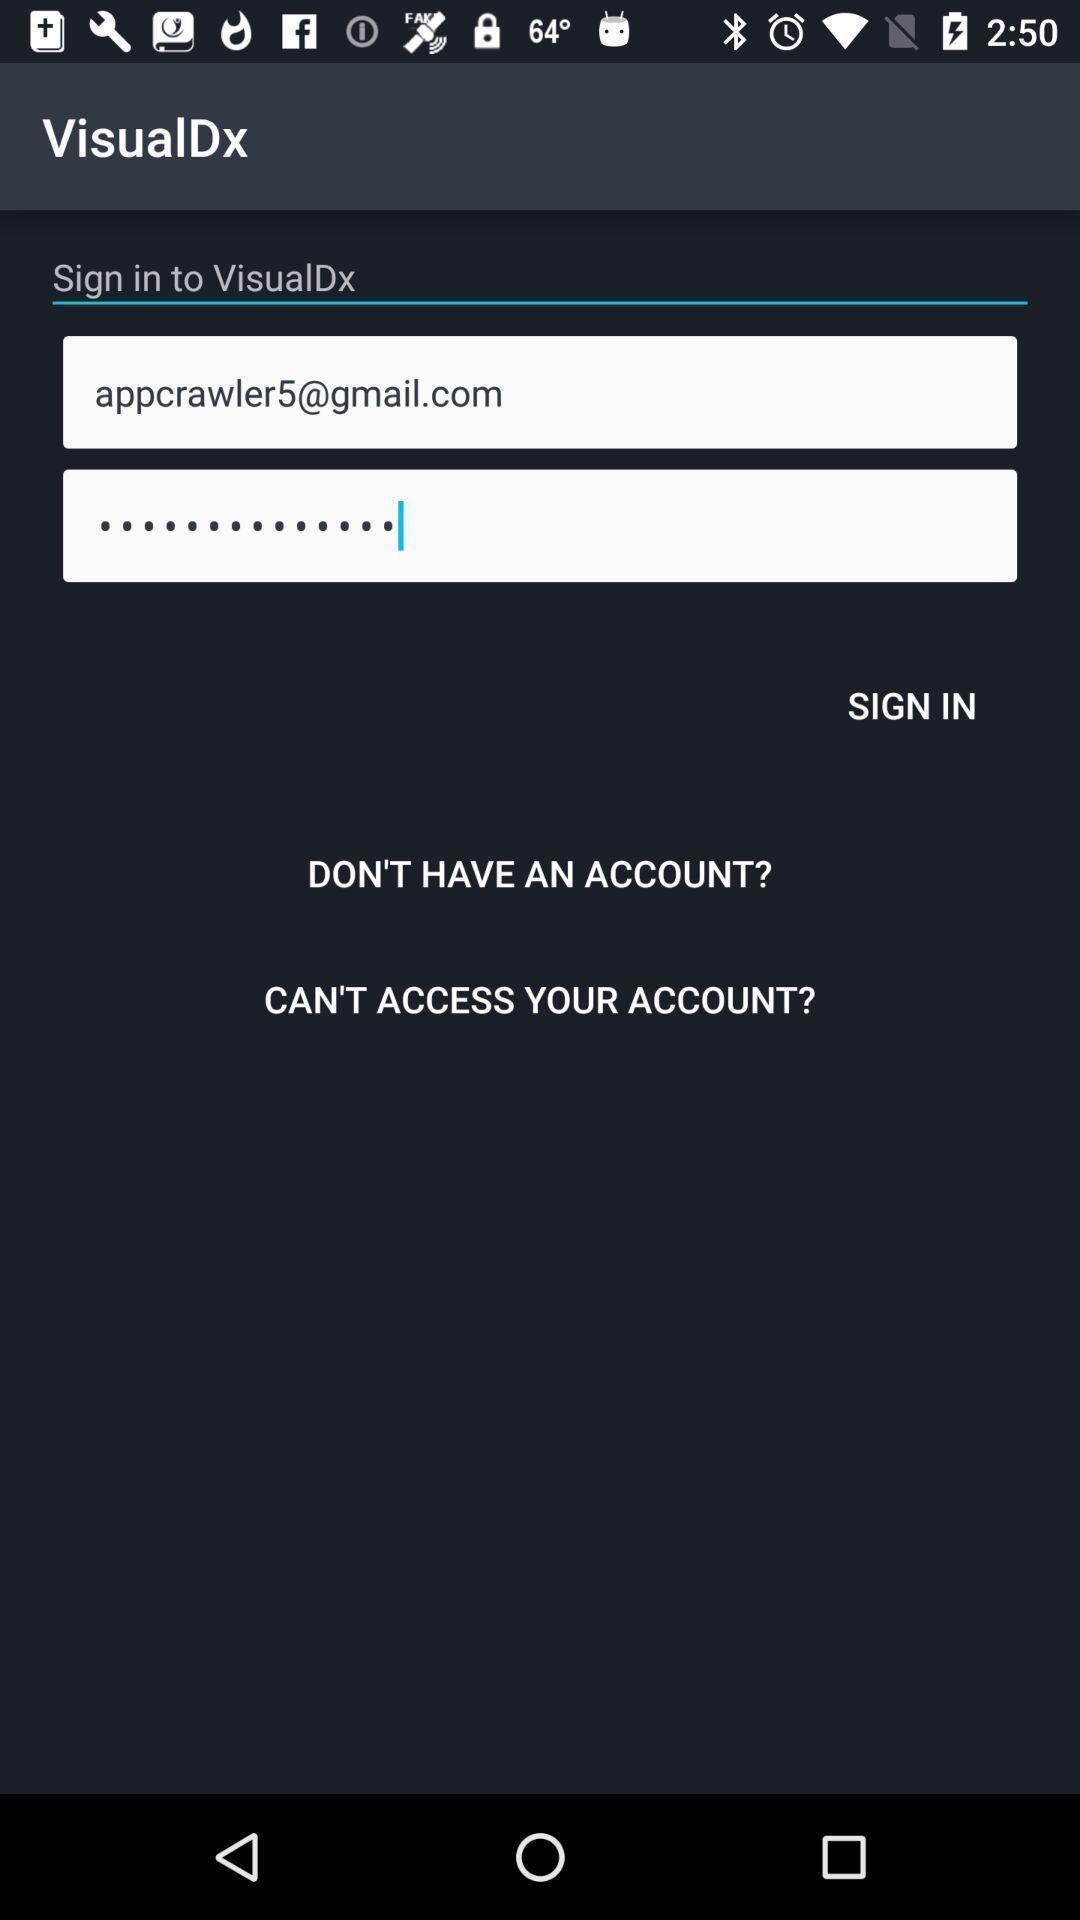What can you discern from this picture? Sign in page. 